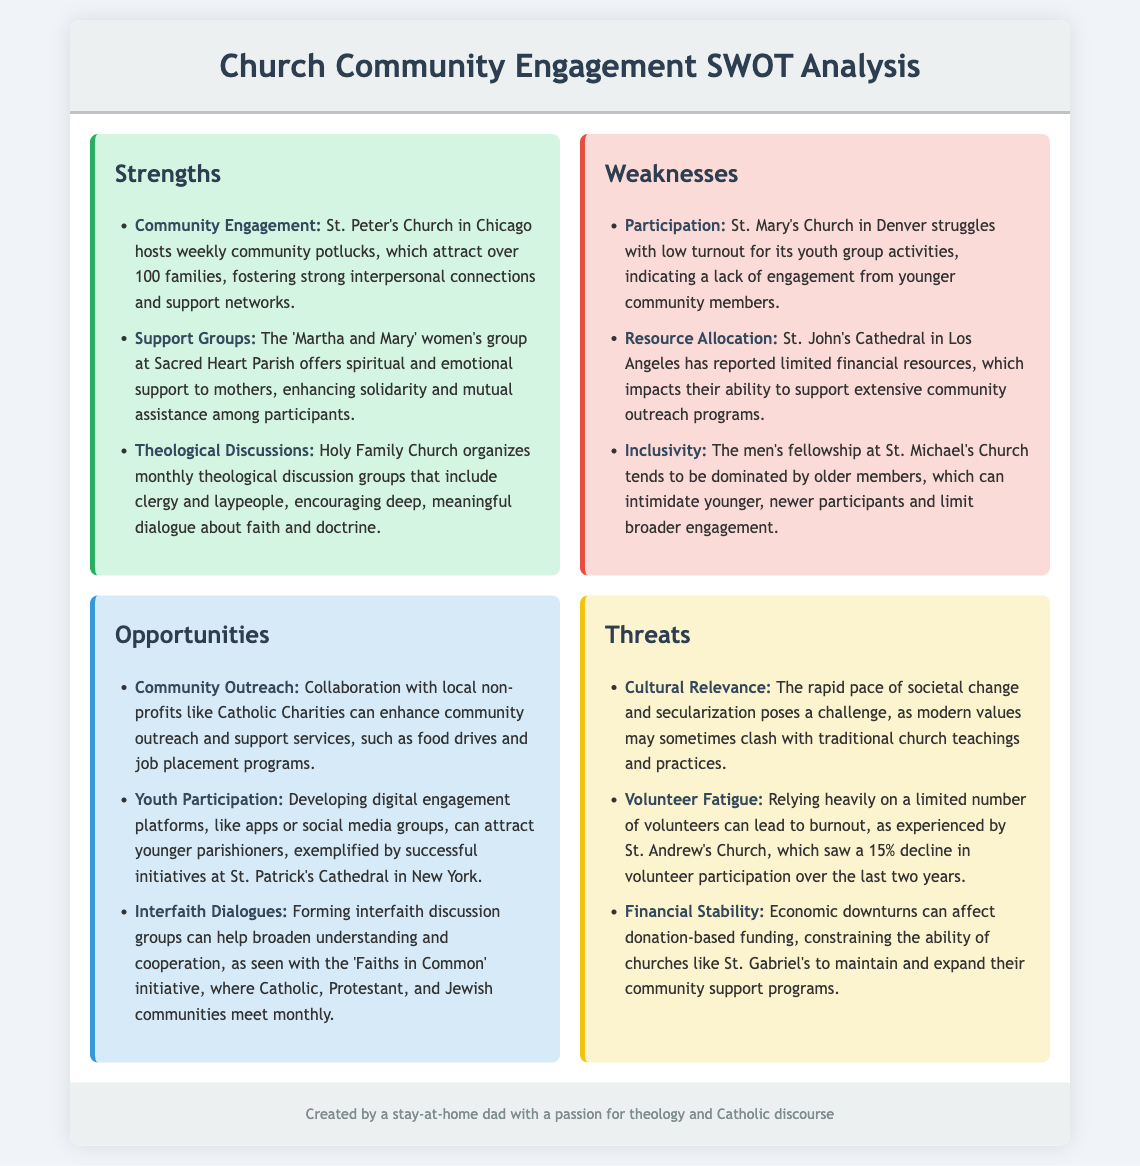What is the name of the women's group at Sacred Heart Parish? The document mentions the 'Martha and Mary' women's group at Sacred Heart Parish that offers support to mothers.
Answer: 'Martha and Mary' How many families attend the weekly community potlucks at St. Peter's Church? The document states that over 100 families attend the weekly community potlucks at St. Peter's Church.
Answer: Over 100 families What is the reported issue at St. Mary's Church regarding youth group activities? The document notes that St. Mary's Church struggles with low turnout for its youth group activities.
Answer: Low turnout What collaboration opportunity is suggested in the document? The document suggests collaboration with local non-profits like Catholic Charities to enhance outreach and support services.
Answer: Local non-profits like Catholic Charities What percentage decline in volunteer participation did St. Andrew's Church experience over the last two years? The document states that St. Andrew's Church saw a 15% decline in volunteer participation over the last two years.
Answer: 15% decline 